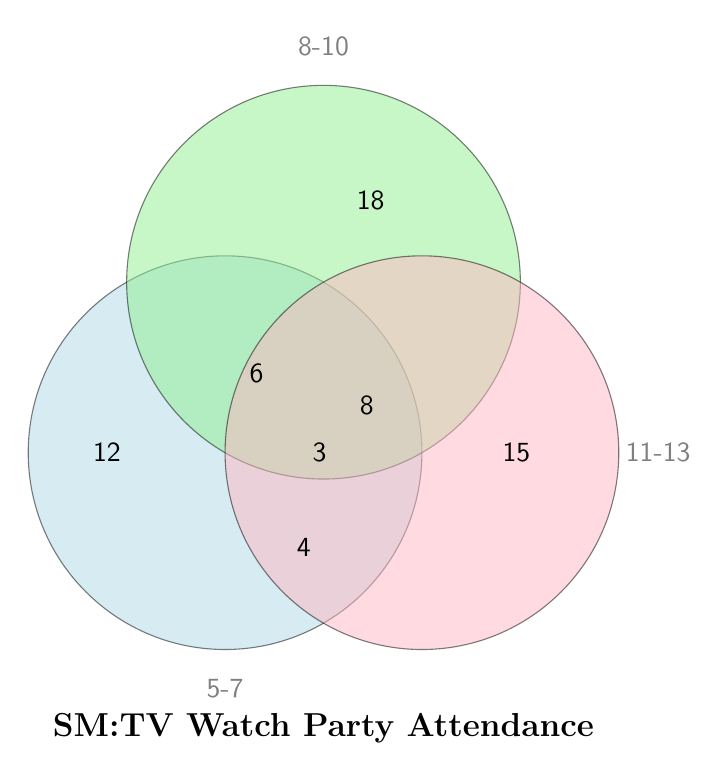What is the title of the Venn diagram? It’s written at the bottom as “SM:TV Watch Party Attendance”
Answer: SM:TV Watch Party Attendance How many children are in the 5-7 years age group? The number is located on the left circle which represents the 5-7 age group
Answer: 12 How many children belong to all three age groups? The number representing "All Ages" is shown in the center where all three circles overlap
Answer: 3 How many children belong to the 8-10 years and 11-13 years age groups but not the 5-7 years group? The number is at the intersection of the 8-10 and 11-13 circles but outside the 5-7 circle
Answer: 8 How many children are in only the 11-13 years age group? The number is in the rightmost circle which represents the 11-13 age group
Answer: 15 Which age group has the highest number of children? Compare the numbers in each age group circle: 5-7 years (12), 8-10 years (18), 11-13 years (15)
Answer: 8-10 years What is the total number of children in the 5-7 and 8-10 age groups without considering overlaps with other groups? Add the children in 5-7 years, 8-10 years, and those in both together: 12 + 18 + 6
Answer: 36 How many children belong to exactly two age groups? Sum the children in only two age group intersections: 6 (5-7 and 8-10) + 8 (8-10 and 11-13) + 4 (5-7 and 11-13)
Answer: 18 Are there more children in the 5-7 years group or the 11-13 years group? Compare the number of children in each: 5-7 years (12) vs. 11-13 years (15)
Answer: 11-13 years How many children belong to at least two age groups? Sum children in the intersections of two and all three age groups: 6 (5-7 and 8-10) + 8 (8-10 and 11-13) + 4 (5-7 and 11-13) + 3 (all three)
Answer: 21 